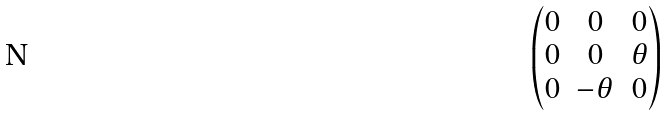<formula> <loc_0><loc_0><loc_500><loc_500>\begin{pmatrix} 0 & 0 & 0 \\ 0 & 0 & \theta \\ 0 & - \theta & 0 \end{pmatrix}</formula> 